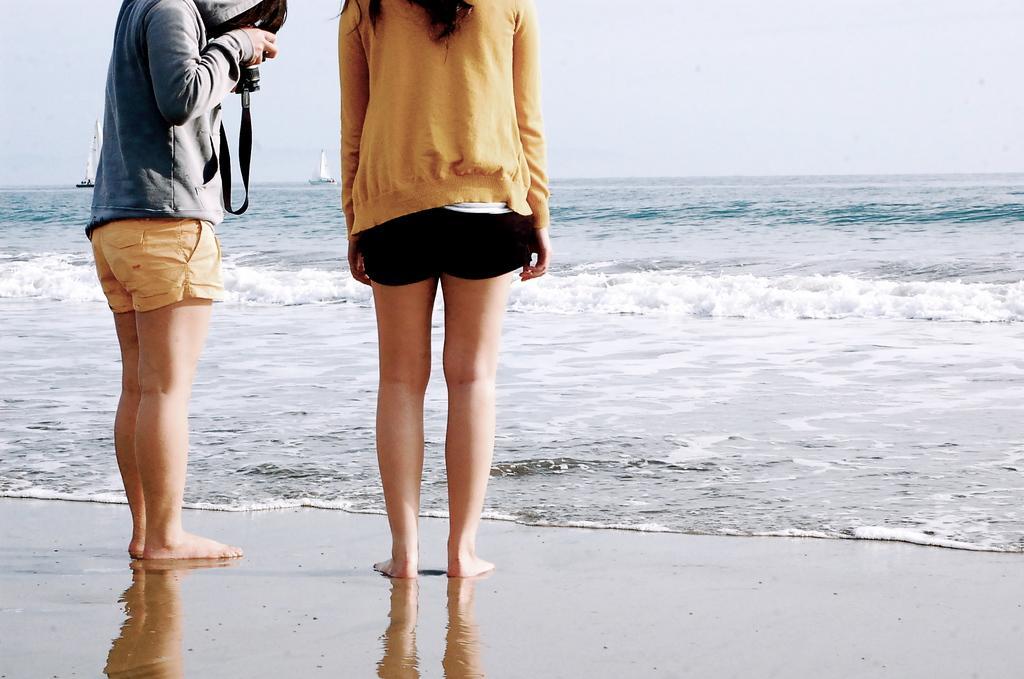Could you give a brief overview of what you see in this image? In the middle of the image two persons are standing. In front of them there is water. Above the water there are some ships. At the top of the image there is sky and he is holding a camera. 